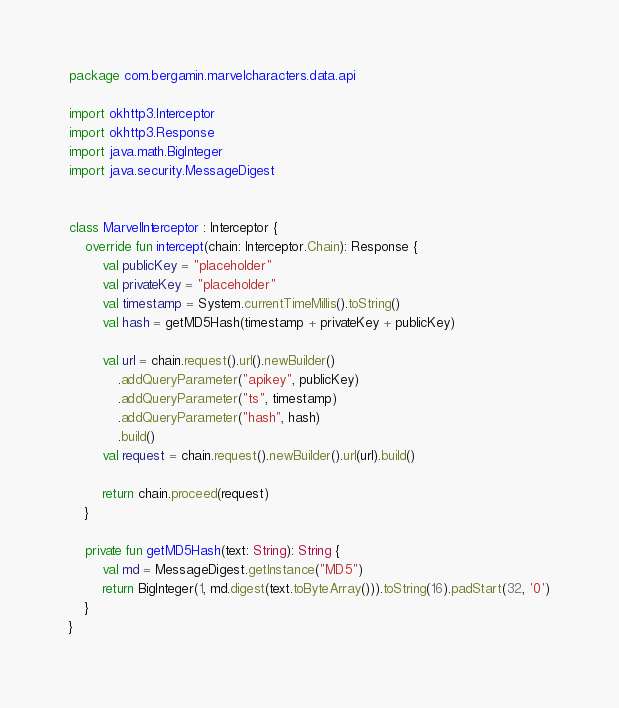<code> <loc_0><loc_0><loc_500><loc_500><_Kotlin_>package com.bergamin.marvelcharacters.data.api

import okhttp3.Interceptor
import okhttp3.Response
import java.math.BigInteger
import java.security.MessageDigest


class MarvelInterceptor : Interceptor {
    override fun intercept(chain: Interceptor.Chain): Response {
        val publicKey = "placeholder"
        val privateKey = "placeholder"
        val timestamp = System.currentTimeMillis().toString()
        val hash = getMD5Hash(timestamp + privateKey + publicKey)

        val url = chain.request().url().newBuilder()
            .addQueryParameter("apikey", publicKey)
            .addQueryParameter("ts", timestamp)
            .addQueryParameter("hash", hash)
            .build()
        val request = chain.request().newBuilder().url(url).build()

        return chain.proceed(request)
    }

    private fun getMD5Hash(text: String): String {
        val md = MessageDigest.getInstance("MD5")
        return BigInteger(1, md.digest(text.toByteArray())).toString(16).padStart(32, '0')
    }
}
</code> 